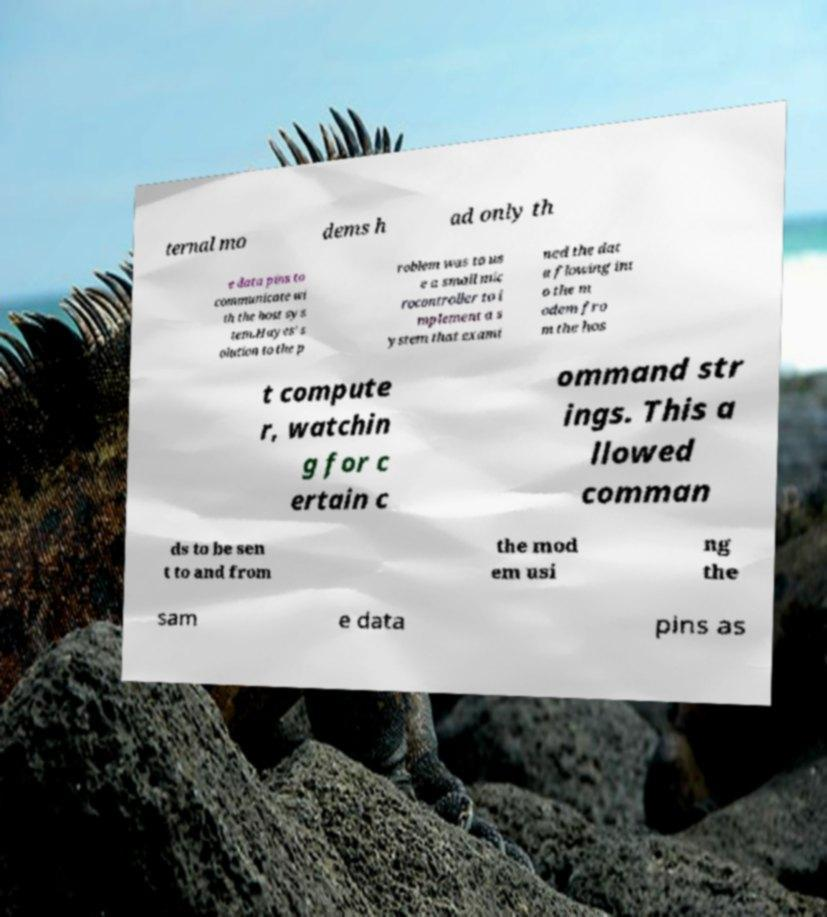Please identify and transcribe the text found in this image. ternal mo dems h ad only th e data pins to communicate wi th the host sys tem.Hayes' s olution to the p roblem was to us e a small mic rocontroller to i mplement a s ystem that exami ned the dat a flowing int o the m odem fro m the hos t compute r, watchin g for c ertain c ommand str ings. This a llowed comman ds to be sen t to and from the mod em usi ng the sam e data pins as 